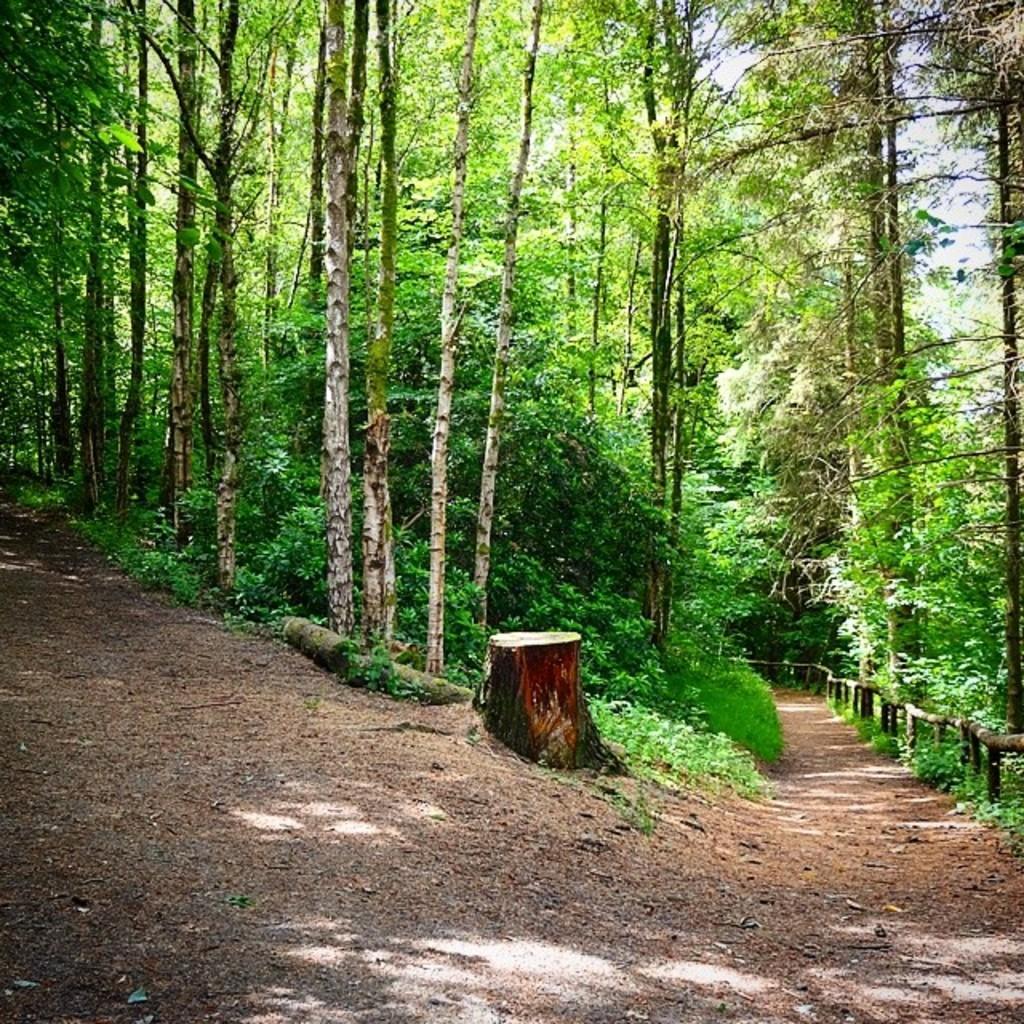Please provide a concise description of this image. As we can see in the image there are trees, wooden logs and sky. 